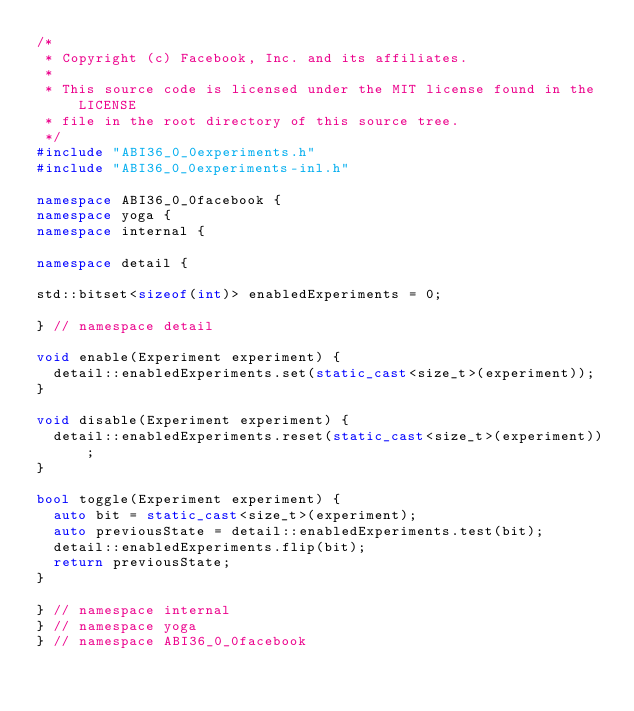Convert code to text. <code><loc_0><loc_0><loc_500><loc_500><_C++_>/*
 * Copyright (c) Facebook, Inc. and its affiliates.
 *
 * This source code is licensed under the MIT license found in the LICENSE
 * file in the root directory of this source tree.
 */
#include "ABI36_0_0experiments.h"
#include "ABI36_0_0experiments-inl.h"

namespace ABI36_0_0facebook {
namespace yoga {
namespace internal {

namespace detail {

std::bitset<sizeof(int)> enabledExperiments = 0;

} // namespace detail

void enable(Experiment experiment) {
  detail::enabledExperiments.set(static_cast<size_t>(experiment));
}

void disable(Experiment experiment) {
  detail::enabledExperiments.reset(static_cast<size_t>(experiment));
}

bool toggle(Experiment experiment) {
  auto bit = static_cast<size_t>(experiment);
  auto previousState = detail::enabledExperiments.test(bit);
  detail::enabledExperiments.flip(bit);
  return previousState;
}

} // namespace internal
} // namespace yoga
} // namespace ABI36_0_0facebook
</code> 